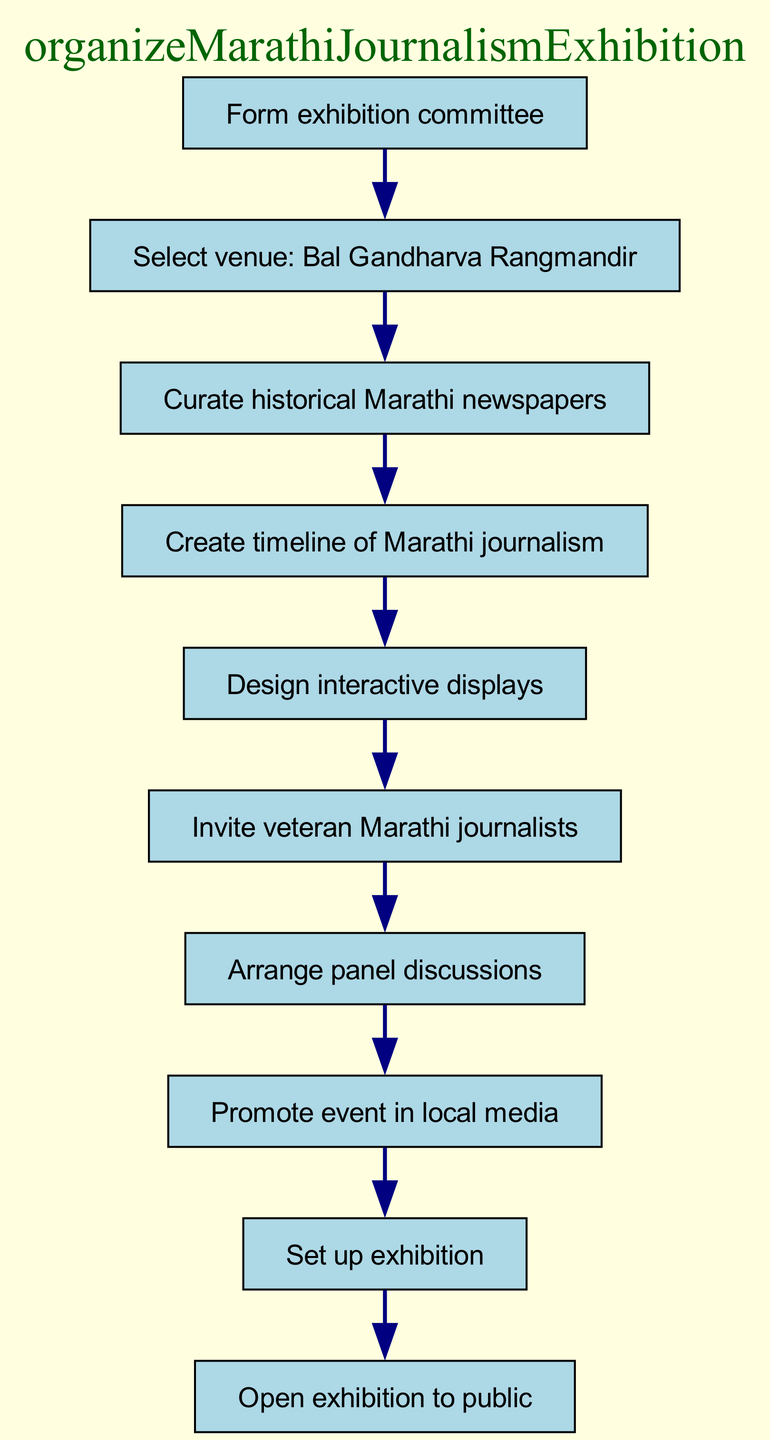What is the first step in organizing the exhibition? The first step according to the diagram is to "Form exhibition committee." This is indicated as the starting point, with no preceding elements.
Answer: Form exhibition committee How many elements are in the flowchart? The flowchart consists of ten elements, each representing a distinct step in the process of organizing the exhibition. This can be counted directly from the list of elements in the diagram.
Answer: 10 What comes after "Invite veteran Marathi journalists"? After "Invite veteran Marathi journalists," the next step in the flowchart is "Arrange panel discussions." This is the immediate following action indicated directly by the flow connection in the diagram.
Answer: Arrange panel discussions Which venue has been selected for the exhibition? The selected venue for the exhibition is "Bal Gandharva Rangmandir," as explicitly stated in the second element of the flowchart.
Answer: Bal Gandharva Rangmandir What is the final action depicted in the diagram? The final action outlined in the flowchart is to "Open exhibition to public." This is the last element and does not have any subsequent steps following it.
Answer: Open exhibition to public What is the relationship between "Curate historical Marathi newspapers" and "Create timeline of Marathi journalism"? "Curate historical Marathi newspapers" leads to "Create timeline of Marathi journalism." This indicates that the curation of newspapers is a prerequisite for the creation of the timeline, showing a sequential dependency.
Answer: Leads to What is the total number of panel discussions arranged? The diagram does not specify the number of panel discussions arranged, just that they are to be arranged as one of the steps in the process. Hence, no specific number is given in the flowchart itself.
Answer: Not specified Which step immediately precedes "Set up exhibition"? The step that immediately precedes "Set up exhibition" is "Promote event in local media." This flow of actions shows that promotion is necessary before the actual setup of the exhibition.
Answer: Promote event in local media Can you identify an interactive component in the organization of the exhibition? Yes, the "Design interactive displays" is clearly identified as an interactive component in the flowchart. This step aims to engage the audience and enhance their experience at the exhibition.
Answer: Design interactive displays 